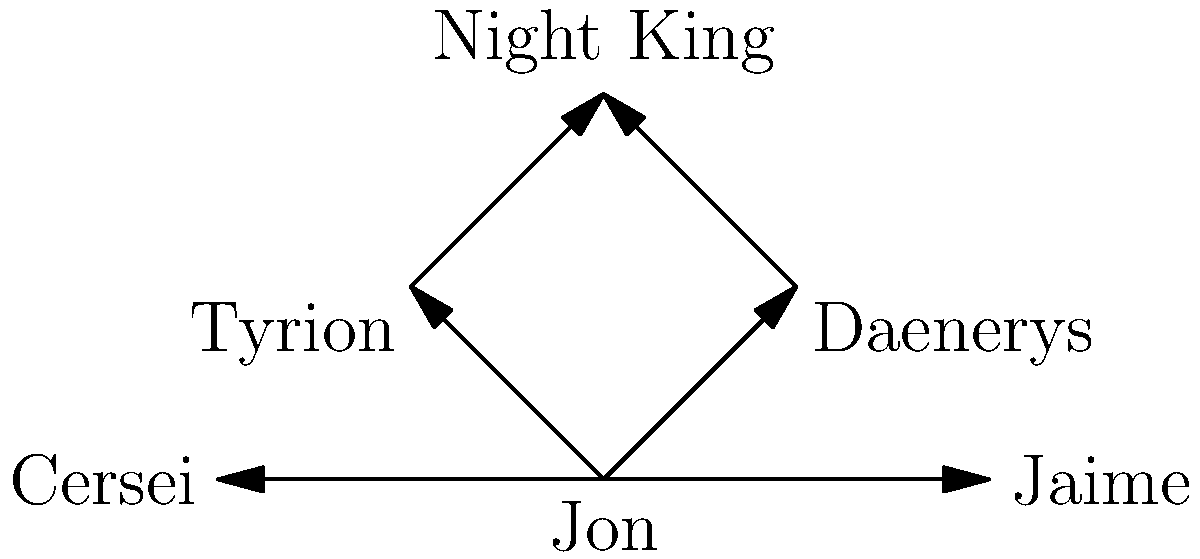In the character relationship network of Game of Thrones shown above, which character has the highest out-degree centrality, and what does this imply about their role in the story? To answer this question, we need to follow these steps:

1. Understand out-degree centrality:
   Out-degree centrality is the number of outgoing edges from a vertex in a directed graph.

2. Count the outgoing edges for each character:
   - Jon: 4 outgoing edges
   - Daenerys: 1 outgoing edge
   - Tyrion: 1 outgoing edge
   - Night King: 0 outgoing edges
   - Cersei: 0 outgoing edges
   - Jaime: 0 outgoing edges

3. Identify the character with the highest out-degree centrality:
   Jon has the highest out-degree centrality with 4 outgoing edges.

4. Interpret the meaning in the context of the story:
   A high out-degree centrality implies that Jon has the most direct influences on other characters in the network. This suggests that Jon is a central figure in the story, likely playing a crucial role in connecting different storylines and influencing the actions of multiple characters.

Therefore, Jon has the highest out-degree centrality, implying that he is a key player in the story with significant influence over other major characters.
Answer: Jon; central character with significant influence over others. 